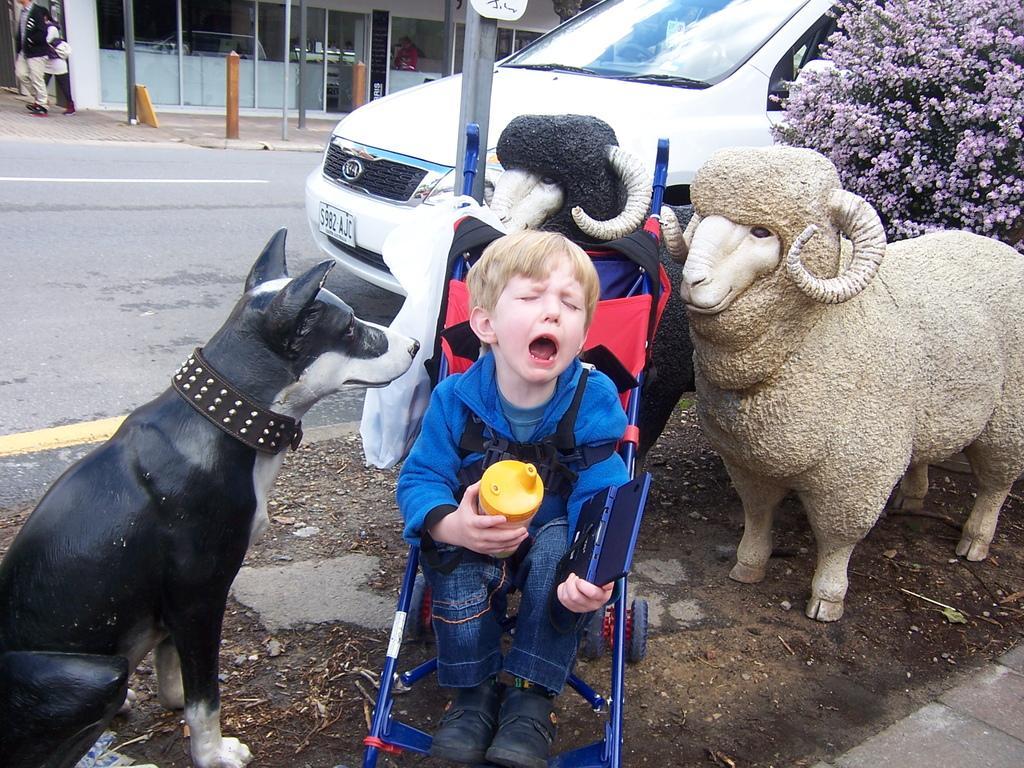Could you give a brief overview of what you see in this image? In the foreground of the picture we can see car, plant, flowers, road, soil, kid, stroller and some toy objects. In the background we can see poles, building, people, footpath, board and other objects. 